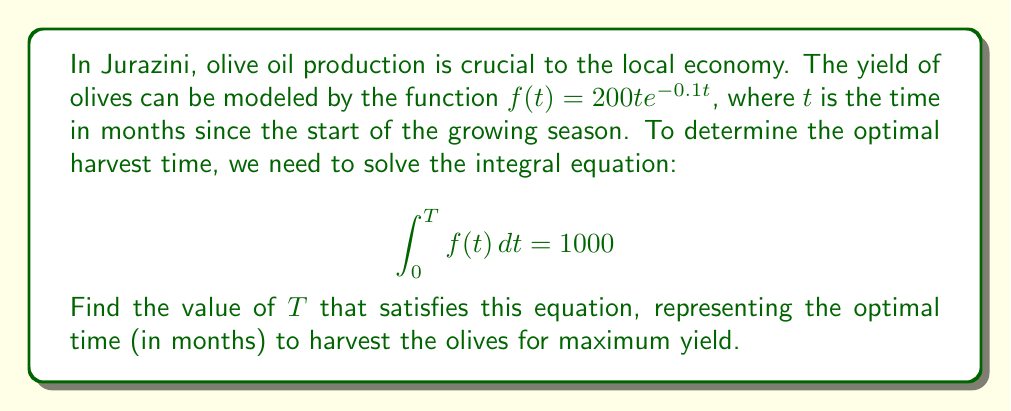Can you answer this question? Let's solve this step-by-step:

1) We start with the integral equation:
   $$\int_0^T 200t e^{-0.1t} dt = 1000$$

2) To solve this, we need to integrate $200t e^{-0.1t}$. Let's use integration by parts:
   Let $u = t$ and $dv = 200e^{-0.1t}dt$
   Then $du = dt$ and $v = -2000e^{-0.1t}$

3) Applying integration by parts:
   $$\int_0^T 200t e^{-0.1t} dt = [-2000te^{-0.1t}]_0^T + \int_0^T 2000e^{-0.1t} dt$$

4) Evaluating the integral:
   $$= [-2000Te^{-0.1T} + 0] + [-20000e^{-0.1t}]_0^T$$
   $$= -2000Te^{-0.1T} + [-20000e^{-0.1T} + 20000]$$

5) Simplifying:
   $$= -2000Te^{-0.1T} - 20000e^{-0.1T} + 20000$$

6) Setting this equal to 1000:
   $$-2000Te^{-0.1T} - 20000e^{-0.1T} + 20000 = 1000$$

7) Simplifying:
   $$-2000Te^{-0.1T} - 20000e^{-0.1T} = -19000$$
   $$e^{-0.1T}(2000T + 20000) = 19000$$

8) This equation cannot be solved algebraically. We need to use numerical methods or a graphing calculator to find the value of $T$ that satisfies this equation.

9) Using numerical methods, we find that $T \approx 10.52$ months.
Answer: $T \approx 10.52$ months 